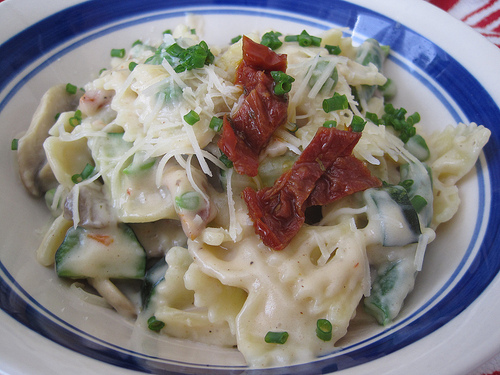<image>
Can you confirm if the bacon is on the pasta? Yes. Looking at the image, I can see the bacon is positioned on top of the pasta, with the pasta providing support. 